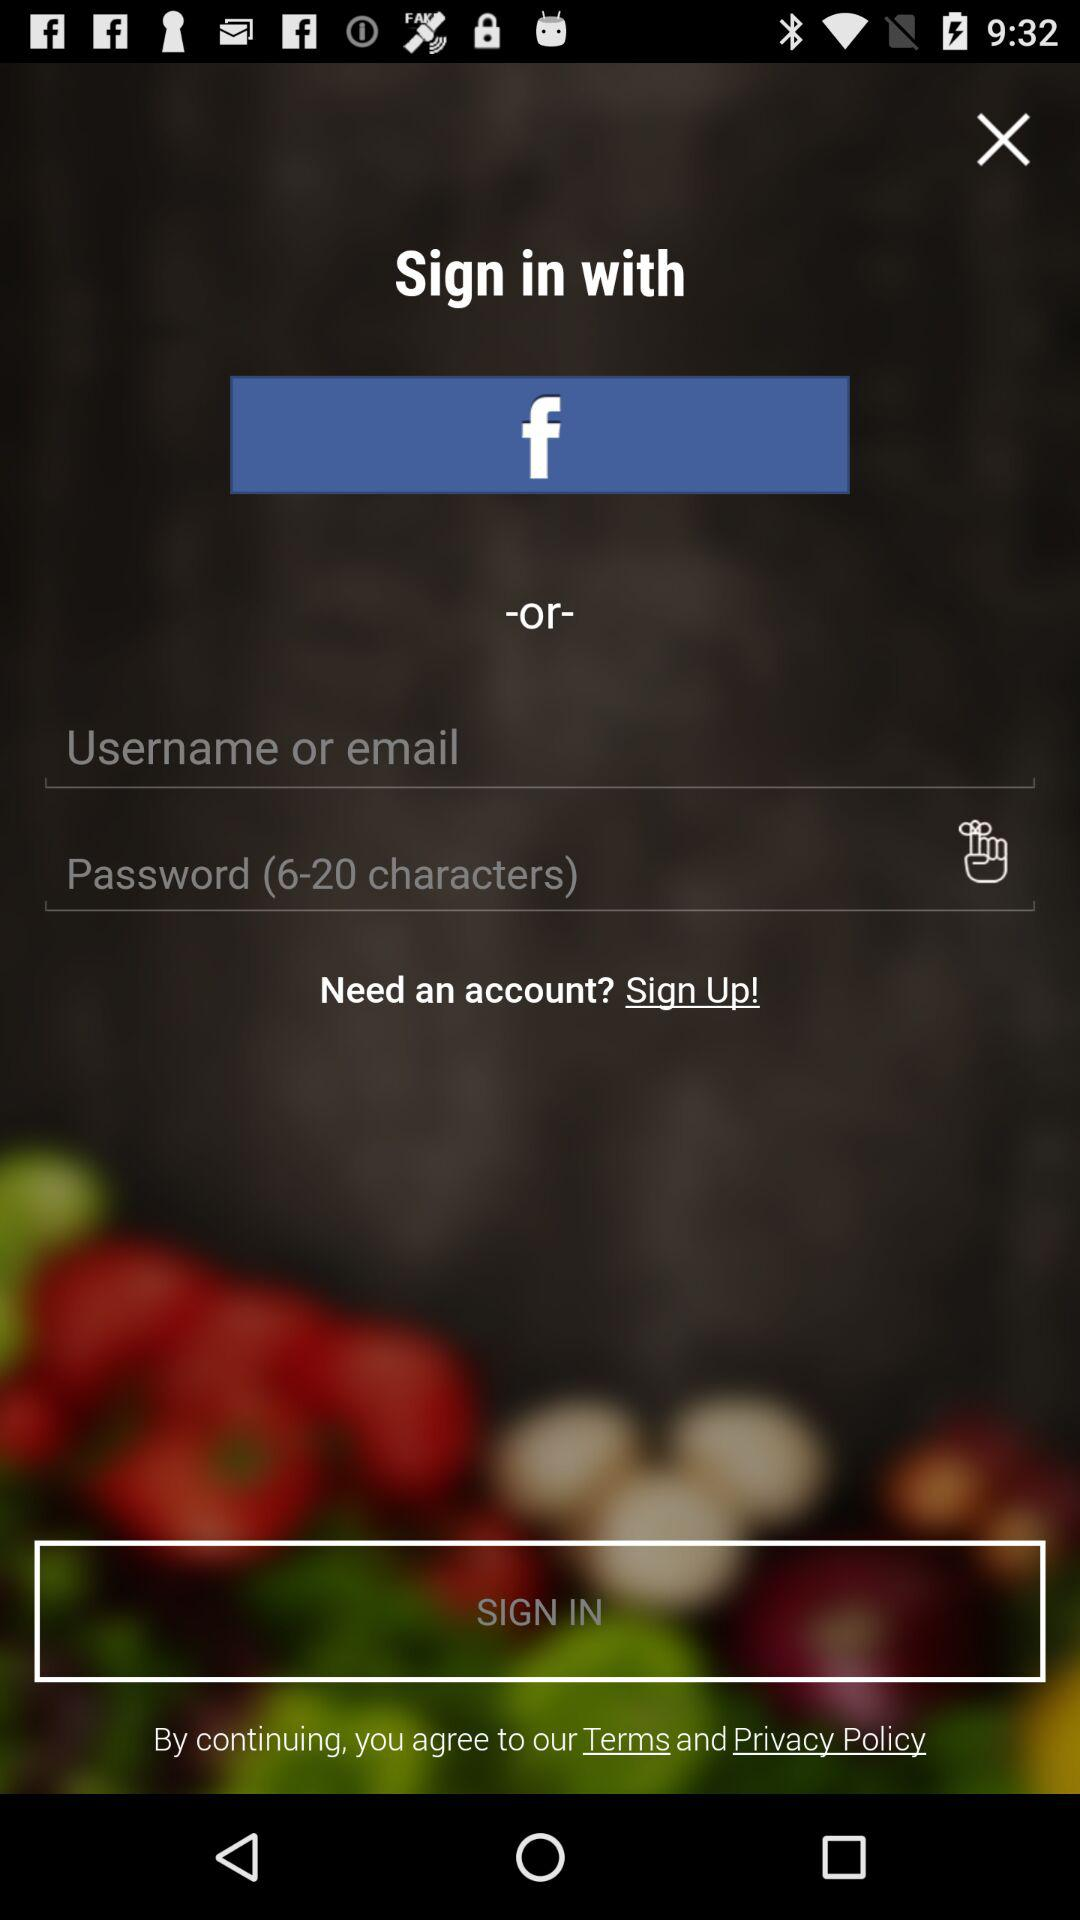How many input fields are there for logging in?
Answer the question using a single word or phrase. 2 